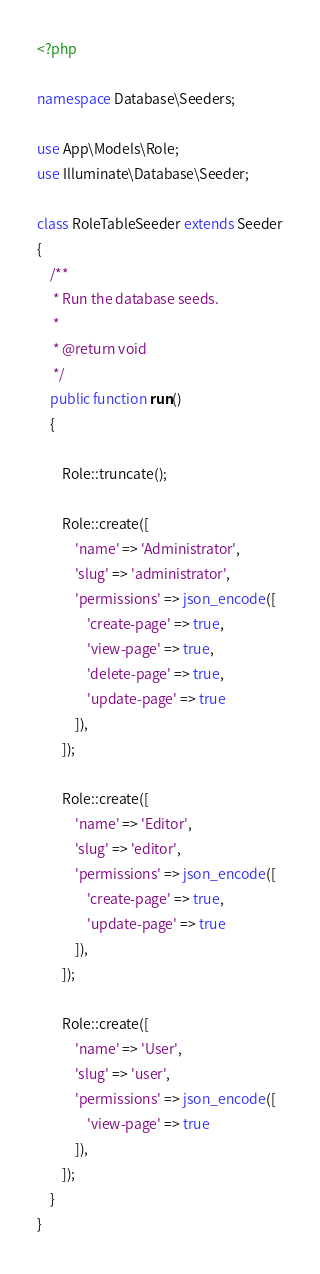Convert code to text. <code><loc_0><loc_0><loc_500><loc_500><_PHP_><?php

namespace Database\Seeders;

use App\Models\Role;
use Illuminate\Database\Seeder;

class RoleTableSeeder extends Seeder
{
    /**
     * Run the database seeds.
     *
     * @return void
     */
    public function run()
    {

        Role::truncate();

        Role::create([
            'name' => 'Administrator',
            'slug' => 'administrator',
            'permissions' => json_encode([
                'create-page' => true,
                'view-page' => true,
                'delete-page' => true,
                'update-page' => true
            ]),
        ]);

        Role::create([
            'name' => 'Editor',
            'slug' => 'editor',
            'permissions' => json_encode([
                'create-page' => true,
                'update-page' => true
            ]),
        ]);

        Role::create([
            'name' => 'User',
            'slug' => 'user',
            'permissions' => json_encode([
                'view-page' => true
            ]),
        ]);
    }
}
</code> 